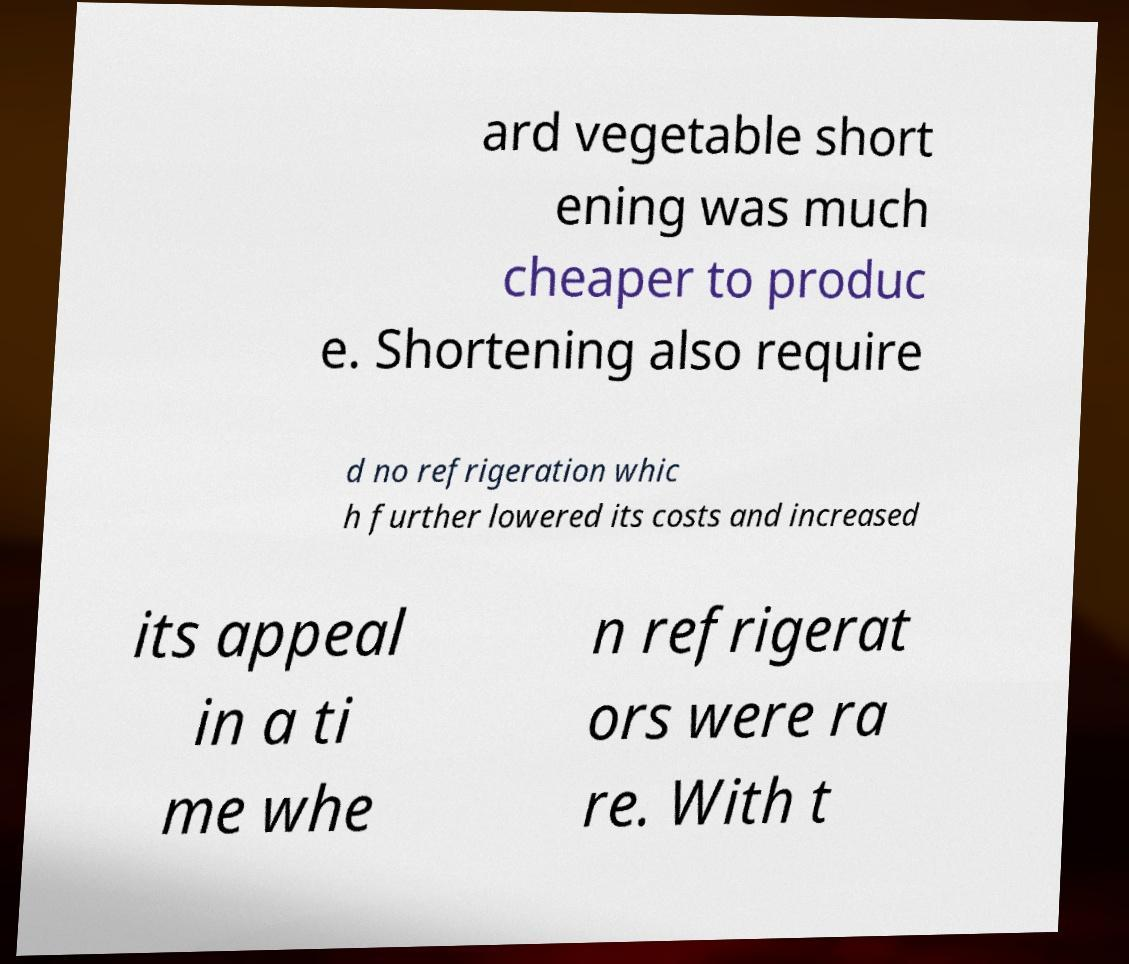What messages or text are displayed in this image? I need them in a readable, typed format. ard vegetable short ening was much cheaper to produc e. Shortening also require d no refrigeration whic h further lowered its costs and increased its appeal in a ti me whe n refrigerat ors were ra re. With t 